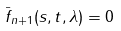<formula> <loc_0><loc_0><loc_500><loc_500>\bar { f } _ { n + 1 } ( s , t , \lambda ) = 0</formula> 